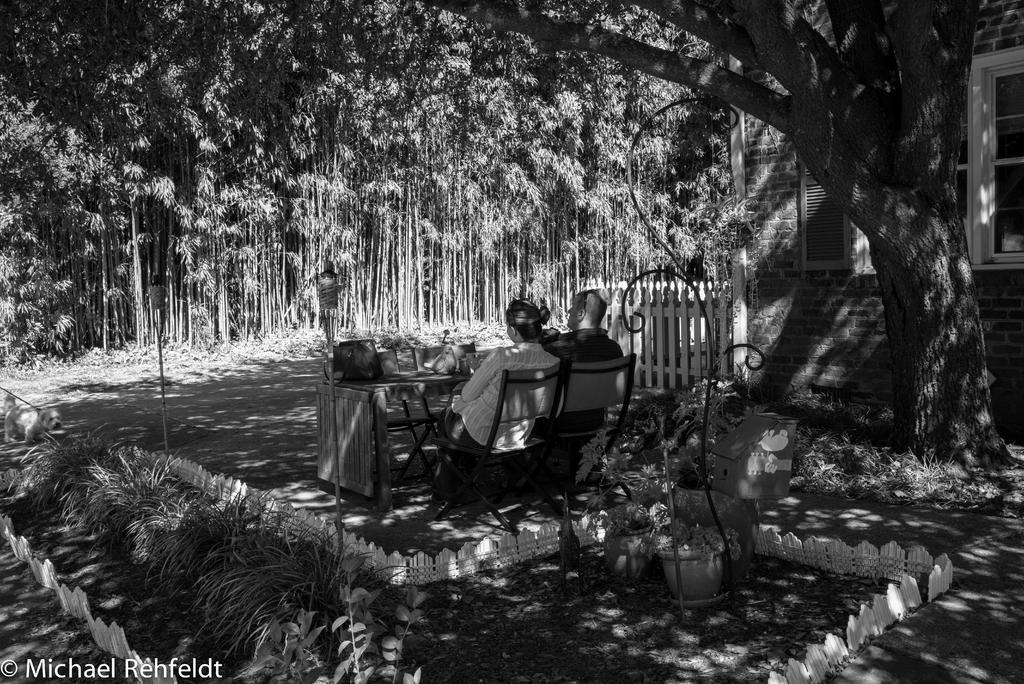In one or two sentences, can you explain what this image depicts? In this image in the center there are persons sitting on chair and in front of the persons there is a table, on the table there are objects. In the background there are trees. On the right side there is a building and there is a fence. In the front on the right side there are plants in the pots. 